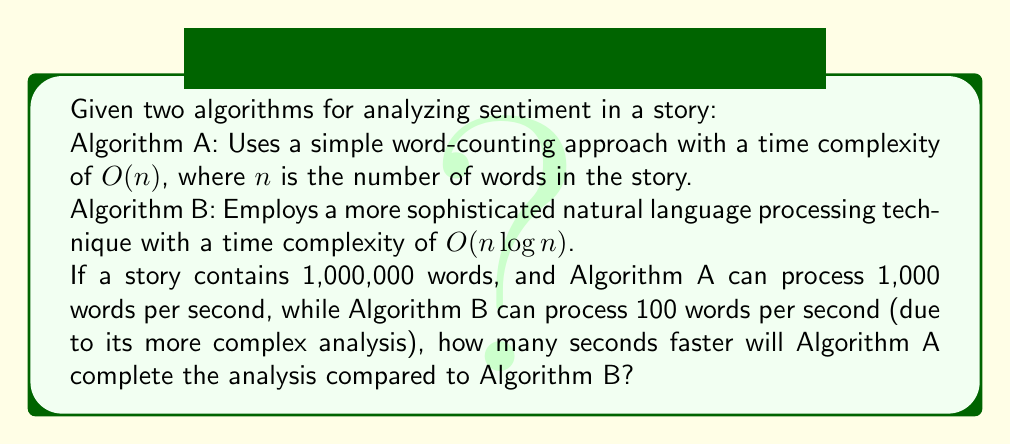Give your solution to this math problem. To solve this problem, we need to calculate the time taken by each algorithm and then find the difference:

1. For Algorithm A:
   - Time complexity: $O(n)$
   - Processing speed: 1,000 words/second
   - Number of words: 1,000,000
   - Time taken = $\frac{1,000,000}{1,000} = 1,000$ seconds

2. For Algorithm B:
   - Time complexity: $O(n \log n)$
   - Processing speed: 100 words/second
   - Number of words: 1,000,000
   - Time taken = $\frac{1,000,000 \times \log_2(1,000,000)}{100}$
   
   To calculate this:
   - $\log_2(1,000,000) \approx 19.93$ (rounded to 2 decimal places)
   - Time taken = $\frac{1,000,000 \times 19.93}{100} \approx 199,300$ seconds

3. Difference in time:
   199,300 - 1,000 = 198,300 seconds

Therefore, Algorithm A will complete the analysis 198,300 seconds faster than Algorithm B.
Answer: 198,300 seconds 